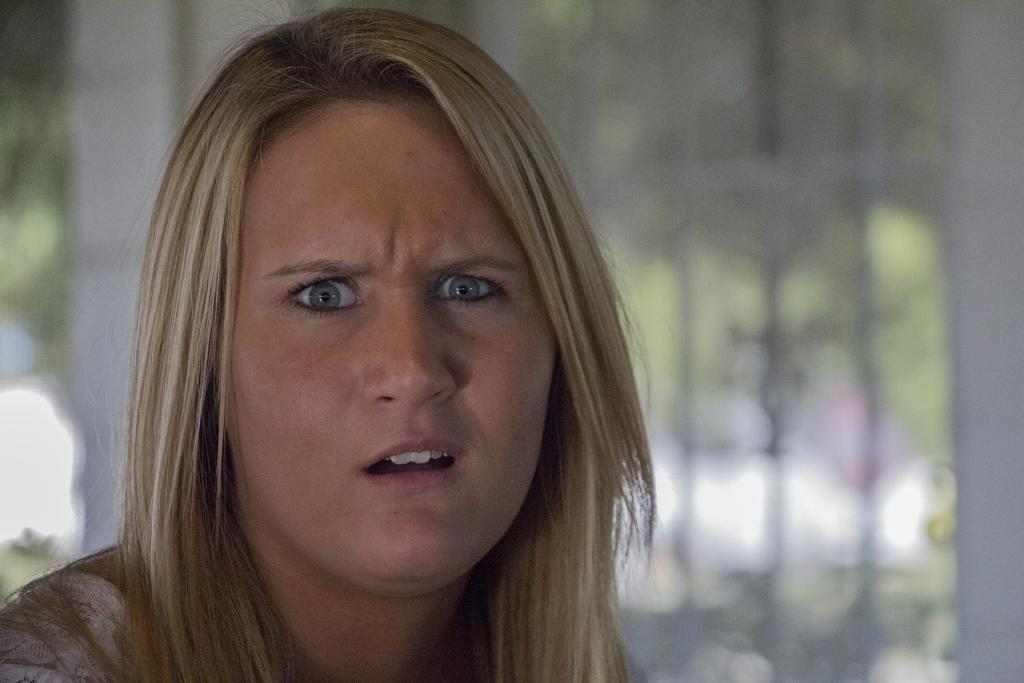Who is the main subject in the image? There is a woman in the image. What can be said about the background of the image? The background of the image is blurry. Despite the blurriness, what can be identified in the background? Trees are visible in the background. What else can be inferred about the background based on the provided facts? There are other objects in the background, but their specific nature is unclear due to the blurriness. What type of meal is being prepared in the image? There is no meal preparation visible in the image; it primarily features a woman and a blurry background. 